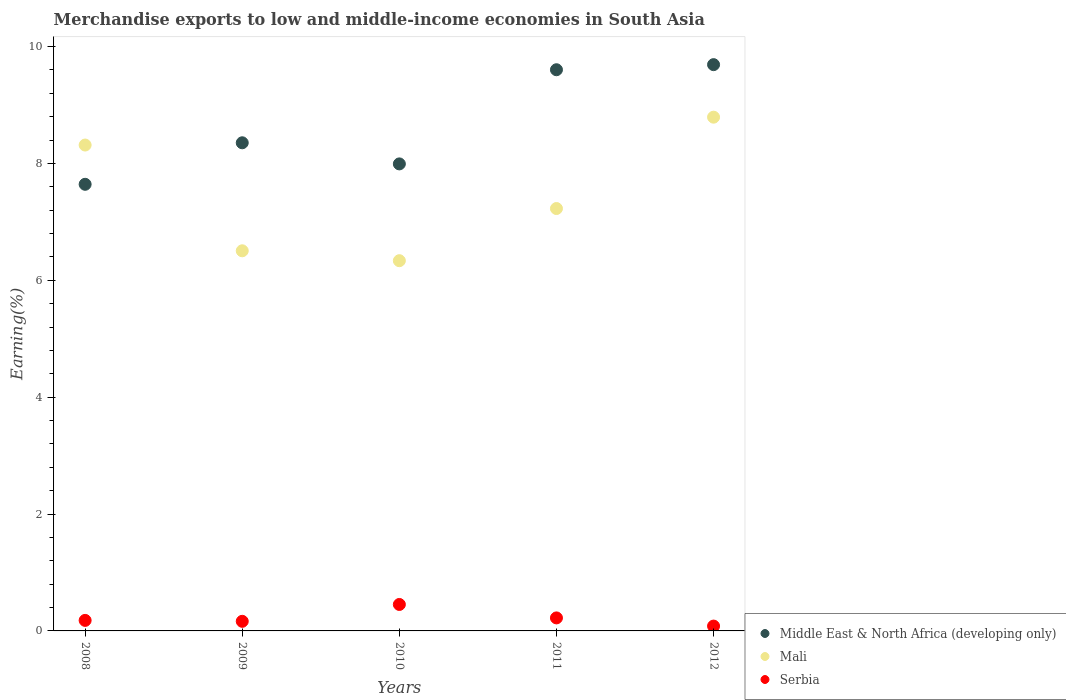How many different coloured dotlines are there?
Give a very brief answer. 3. What is the percentage of amount earned from merchandise exports in Mali in 2008?
Give a very brief answer. 8.31. Across all years, what is the maximum percentage of amount earned from merchandise exports in Serbia?
Make the answer very short. 0.45. Across all years, what is the minimum percentage of amount earned from merchandise exports in Mali?
Keep it short and to the point. 6.34. In which year was the percentage of amount earned from merchandise exports in Middle East & North Africa (developing only) maximum?
Your response must be concise. 2012. In which year was the percentage of amount earned from merchandise exports in Serbia minimum?
Your answer should be compact. 2012. What is the total percentage of amount earned from merchandise exports in Middle East & North Africa (developing only) in the graph?
Your answer should be compact. 43.28. What is the difference between the percentage of amount earned from merchandise exports in Middle East & North Africa (developing only) in 2008 and that in 2009?
Keep it short and to the point. -0.71. What is the difference between the percentage of amount earned from merchandise exports in Serbia in 2008 and the percentage of amount earned from merchandise exports in Middle East & North Africa (developing only) in 2009?
Give a very brief answer. -8.17. What is the average percentage of amount earned from merchandise exports in Mali per year?
Offer a very short reply. 7.43. In the year 2010, what is the difference between the percentage of amount earned from merchandise exports in Middle East & North Africa (developing only) and percentage of amount earned from merchandise exports in Mali?
Ensure brevity in your answer.  1.66. In how many years, is the percentage of amount earned from merchandise exports in Serbia greater than 5.2 %?
Keep it short and to the point. 0. What is the ratio of the percentage of amount earned from merchandise exports in Middle East & North Africa (developing only) in 2008 to that in 2010?
Your answer should be very brief. 0.96. Is the difference between the percentage of amount earned from merchandise exports in Middle East & North Africa (developing only) in 2009 and 2012 greater than the difference between the percentage of amount earned from merchandise exports in Mali in 2009 and 2012?
Make the answer very short. Yes. What is the difference between the highest and the second highest percentage of amount earned from merchandise exports in Serbia?
Offer a very short reply. 0.23. What is the difference between the highest and the lowest percentage of amount earned from merchandise exports in Middle East & North Africa (developing only)?
Your answer should be compact. 2.05. Is it the case that in every year, the sum of the percentage of amount earned from merchandise exports in Serbia and percentage of amount earned from merchandise exports in Mali  is greater than the percentage of amount earned from merchandise exports in Middle East & North Africa (developing only)?
Provide a short and direct response. No. Does the percentage of amount earned from merchandise exports in Middle East & North Africa (developing only) monotonically increase over the years?
Provide a succinct answer. No. What is the difference between two consecutive major ticks on the Y-axis?
Your answer should be compact. 2. Does the graph contain any zero values?
Ensure brevity in your answer.  No. Does the graph contain grids?
Offer a very short reply. No. What is the title of the graph?
Offer a terse response. Merchandise exports to low and middle-income economies in South Asia. What is the label or title of the Y-axis?
Your answer should be compact. Earning(%). What is the Earning(%) of Middle East & North Africa (developing only) in 2008?
Keep it short and to the point. 7.64. What is the Earning(%) in Mali in 2008?
Give a very brief answer. 8.31. What is the Earning(%) in Serbia in 2008?
Offer a terse response. 0.18. What is the Earning(%) of Middle East & North Africa (developing only) in 2009?
Offer a very short reply. 8.35. What is the Earning(%) of Mali in 2009?
Ensure brevity in your answer.  6.5. What is the Earning(%) of Serbia in 2009?
Provide a succinct answer. 0.16. What is the Earning(%) of Middle East & North Africa (developing only) in 2010?
Your response must be concise. 7.99. What is the Earning(%) of Mali in 2010?
Offer a terse response. 6.34. What is the Earning(%) of Serbia in 2010?
Your answer should be very brief. 0.45. What is the Earning(%) in Middle East & North Africa (developing only) in 2011?
Your answer should be compact. 9.6. What is the Earning(%) in Mali in 2011?
Offer a terse response. 7.23. What is the Earning(%) of Serbia in 2011?
Provide a short and direct response. 0.22. What is the Earning(%) in Middle East & North Africa (developing only) in 2012?
Make the answer very short. 9.69. What is the Earning(%) of Mali in 2012?
Your answer should be very brief. 8.79. What is the Earning(%) in Serbia in 2012?
Ensure brevity in your answer.  0.08. Across all years, what is the maximum Earning(%) of Middle East & North Africa (developing only)?
Keep it short and to the point. 9.69. Across all years, what is the maximum Earning(%) in Mali?
Offer a very short reply. 8.79. Across all years, what is the maximum Earning(%) in Serbia?
Ensure brevity in your answer.  0.45. Across all years, what is the minimum Earning(%) of Middle East & North Africa (developing only)?
Your answer should be very brief. 7.64. Across all years, what is the minimum Earning(%) in Mali?
Your answer should be very brief. 6.34. Across all years, what is the minimum Earning(%) in Serbia?
Make the answer very short. 0.08. What is the total Earning(%) of Middle East & North Africa (developing only) in the graph?
Provide a succinct answer. 43.28. What is the total Earning(%) of Mali in the graph?
Offer a terse response. 37.17. What is the total Earning(%) in Serbia in the graph?
Provide a succinct answer. 1.1. What is the difference between the Earning(%) in Middle East & North Africa (developing only) in 2008 and that in 2009?
Keep it short and to the point. -0.71. What is the difference between the Earning(%) of Mali in 2008 and that in 2009?
Keep it short and to the point. 1.81. What is the difference between the Earning(%) in Serbia in 2008 and that in 2009?
Your answer should be compact. 0.02. What is the difference between the Earning(%) of Middle East & North Africa (developing only) in 2008 and that in 2010?
Your response must be concise. -0.35. What is the difference between the Earning(%) in Mali in 2008 and that in 2010?
Your answer should be very brief. 1.98. What is the difference between the Earning(%) of Serbia in 2008 and that in 2010?
Make the answer very short. -0.27. What is the difference between the Earning(%) in Middle East & North Africa (developing only) in 2008 and that in 2011?
Provide a succinct answer. -1.96. What is the difference between the Earning(%) in Mali in 2008 and that in 2011?
Ensure brevity in your answer.  1.09. What is the difference between the Earning(%) in Serbia in 2008 and that in 2011?
Your answer should be compact. -0.04. What is the difference between the Earning(%) of Middle East & North Africa (developing only) in 2008 and that in 2012?
Keep it short and to the point. -2.05. What is the difference between the Earning(%) in Mali in 2008 and that in 2012?
Your response must be concise. -0.48. What is the difference between the Earning(%) in Serbia in 2008 and that in 2012?
Offer a very short reply. 0.1. What is the difference between the Earning(%) of Middle East & North Africa (developing only) in 2009 and that in 2010?
Give a very brief answer. 0.36. What is the difference between the Earning(%) in Mali in 2009 and that in 2010?
Your answer should be very brief. 0.17. What is the difference between the Earning(%) of Serbia in 2009 and that in 2010?
Your answer should be compact. -0.29. What is the difference between the Earning(%) in Middle East & North Africa (developing only) in 2009 and that in 2011?
Give a very brief answer. -1.25. What is the difference between the Earning(%) of Mali in 2009 and that in 2011?
Your response must be concise. -0.72. What is the difference between the Earning(%) in Serbia in 2009 and that in 2011?
Provide a succinct answer. -0.06. What is the difference between the Earning(%) in Middle East & North Africa (developing only) in 2009 and that in 2012?
Your answer should be compact. -1.34. What is the difference between the Earning(%) of Mali in 2009 and that in 2012?
Your response must be concise. -2.29. What is the difference between the Earning(%) in Serbia in 2009 and that in 2012?
Offer a terse response. 0.08. What is the difference between the Earning(%) of Middle East & North Africa (developing only) in 2010 and that in 2011?
Your response must be concise. -1.61. What is the difference between the Earning(%) in Mali in 2010 and that in 2011?
Your response must be concise. -0.89. What is the difference between the Earning(%) of Serbia in 2010 and that in 2011?
Keep it short and to the point. 0.23. What is the difference between the Earning(%) in Middle East & North Africa (developing only) in 2010 and that in 2012?
Your answer should be very brief. -1.7. What is the difference between the Earning(%) in Mali in 2010 and that in 2012?
Keep it short and to the point. -2.46. What is the difference between the Earning(%) in Serbia in 2010 and that in 2012?
Give a very brief answer. 0.37. What is the difference between the Earning(%) in Middle East & North Africa (developing only) in 2011 and that in 2012?
Offer a very short reply. -0.09. What is the difference between the Earning(%) of Mali in 2011 and that in 2012?
Your response must be concise. -1.56. What is the difference between the Earning(%) in Serbia in 2011 and that in 2012?
Your answer should be compact. 0.14. What is the difference between the Earning(%) of Middle East & North Africa (developing only) in 2008 and the Earning(%) of Mali in 2009?
Your response must be concise. 1.14. What is the difference between the Earning(%) of Middle East & North Africa (developing only) in 2008 and the Earning(%) of Serbia in 2009?
Offer a terse response. 7.48. What is the difference between the Earning(%) in Mali in 2008 and the Earning(%) in Serbia in 2009?
Your answer should be compact. 8.15. What is the difference between the Earning(%) in Middle East & North Africa (developing only) in 2008 and the Earning(%) in Mali in 2010?
Give a very brief answer. 1.31. What is the difference between the Earning(%) in Middle East & North Africa (developing only) in 2008 and the Earning(%) in Serbia in 2010?
Provide a succinct answer. 7.19. What is the difference between the Earning(%) in Mali in 2008 and the Earning(%) in Serbia in 2010?
Offer a terse response. 7.86. What is the difference between the Earning(%) in Middle East & North Africa (developing only) in 2008 and the Earning(%) in Mali in 2011?
Offer a terse response. 0.41. What is the difference between the Earning(%) of Middle East & North Africa (developing only) in 2008 and the Earning(%) of Serbia in 2011?
Offer a very short reply. 7.42. What is the difference between the Earning(%) of Mali in 2008 and the Earning(%) of Serbia in 2011?
Provide a short and direct response. 8.09. What is the difference between the Earning(%) of Middle East & North Africa (developing only) in 2008 and the Earning(%) of Mali in 2012?
Your response must be concise. -1.15. What is the difference between the Earning(%) of Middle East & North Africa (developing only) in 2008 and the Earning(%) of Serbia in 2012?
Your answer should be compact. 7.56. What is the difference between the Earning(%) in Mali in 2008 and the Earning(%) in Serbia in 2012?
Provide a short and direct response. 8.23. What is the difference between the Earning(%) of Middle East & North Africa (developing only) in 2009 and the Earning(%) of Mali in 2010?
Provide a short and direct response. 2.02. What is the difference between the Earning(%) of Middle East & North Africa (developing only) in 2009 and the Earning(%) of Serbia in 2010?
Offer a terse response. 7.9. What is the difference between the Earning(%) in Mali in 2009 and the Earning(%) in Serbia in 2010?
Offer a very short reply. 6.05. What is the difference between the Earning(%) in Middle East & North Africa (developing only) in 2009 and the Earning(%) in Mali in 2011?
Provide a short and direct response. 1.12. What is the difference between the Earning(%) in Middle East & North Africa (developing only) in 2009 and the Earning(%) in Serbia in 2011?
Provide a succinct answer. 8.13. What is the difference between the Earning(%) of Mali in 2009 and the Earning(%) of Serbia in 2011?
Make the answer very short. 6.28. What is the difference between the Earning(%) of Middle East & North Africa (developing only) in 2009 and the Earning(%) of Mali in 2012?
Make the answer very short. -0.44. What is the difference between the Earning(%) in Middle East & North Africa (developing only) in 2009 and the Earning(%) in Serbia in 2012?
Ensure brevity in your answer.  8.27. What is the difference between the Earning(%) in Mali in 2009 and the Earning(%) in Serbia in 2012?
Your answer should be very brief. 6.42. What is the difference between the Earning(%) in Middle East & North Africa (developing only) in 2010 and the Earning(%) in Mali in 2011?
Offer a terse response. 0.76. What is the difference between the Earning(%) in Middle East & North Africa (developing only) in 2010 and the Earning(%) in Serbia in 2011?
Keep it short and to the point. 7.77. What is the difference between the Earning(%) in Mali in 2010 and the Earning(%) in Serbia in 2011?
Make the answer very short. 6.11. What is the difference between the Earning(%) in Middle East & North Africa (developing only) in 2010 and the Earning(%) in Mali in 2012?
Your answer should be compact. -0.8. What is the difference between the Earning(%) of Middle East & North Africa (developing only) in 2010 and the Earning(%) of Serbia in 2012?
Make the answer very short. 7.91. What is the difference between the Earning(%) of Mali in 2010 and the Earning(%) of Serbia in 2012?
Your answer should be very brief. 6.25. What is the difference between the Earning(%) in Middle East & North Africa (developing only) in 2011 and the Earning(%) in Mali in 2012?
Provide a succinct answer. 0.81. What is the difference between the Earning(%) in Middle East & North Africa (developing only) in 2011 and the Earning(%) in Serbia in 2012?
Keep it short and to the point. 9.52. What is the difference between the Earning(%) in Mali in 2011 and the Earning(%) in Serbia in 2012?
Offer a very short reply. 7.14. What is the average Earning(%) of Middle East & North Africa (developing only) per year?
Make the answer very short. 8.66. What is the average Earning(%) of Mali per year?
Provide a short and direct response. 7.43. What is the average Earning(%) in Serbia per year?
Your answer should be very brief. 0.22. In the year 2008, what is the difference between the Earning(%) in Middle East & North Africa (developing only) and Earning(%) in Mali?
Your answer should be very brief. -0.67. In the year 2008, what is the difference between the Earning(%) of Middle East & North Africa (developing only) and Earning(%) of Serbia?
Your answer should be compact. 7.46. In the year 2008, what is the difference between the Earning(%) in Mali and Earning(%) in Serbia?
Keep it short and to the point. 8.13. In the year 2009, what is the difference between the Earning(%) in Middle East & North Africa (developing only) and Earning(%) in Mali?
Make the answer very short. 1.85. In the year 2009, what is the difference between the Earning(%) in Middle East & North Africa (developing only) and Earning(%) in Serbia?
Provide a succinct answer. 8.19. In the year 2009, what is the difference between the Earning(%) of Mali and Earning(%) of Serbia?
Offer a terse response. 6.34. In the year 2010, what is the difference between the Earning(%) of Middle East & North Africa (developing only) and Earning(%) of Mali?
Offer a very short reply. 1.66. In the year 2010, what is the difference between the Earning(%) in Middle East & North Africa (developing only) and Earning(%) in Serbia?
Your response must be concise. 7.54. In the year 2010, what is the difference between the Earning(%) of Mali and Earning(%) of Serbia?
Your answer should be compact. 5.88. In the year 2011, what is the difference between the Earning(%) in Middle East & North Africa (developing only) and Earning(%) in Mali?
Make the answer very short. 2.37. In the year 2011, what is the difference between the Earning(%) in Middle East & North Africa (developing only) and Earning(%) in Serbia?
Your response must be concise. 9.38. In the year 2011, what is the difference between the Earning(%) in Mali and Earning(%) in Serbia?
Offer a very short reply. 7.01. In the year 2012, what is the difference between the Earning(%) of Middle East & North Africa (developing only) and Earning(%) of Mali?
Offer a very short reply. 0.9. In the year 2012, what is the difference between the Earning(%) in Middle East & North Africa (developing only) and Earning(%) in Serbia?
Provide a succinct answer. 9.61. In the year 2012, what is the difference between the Earning(%) of Mali and Earning(%) of Serbia?
Make the answer very short. 8.71. What is the ratio of the Earning(%) in Middle East & North Africa (developing only) in 2008 to that in 2009?
Keep it short and to the point. 0.92. What is the ratio of the Earning(%) in Mali in 2008 to that in 2009?
Make the answer very short. 1.28. What is the ratio of the Earning(%) of Serbia in 2008 to that in 2009?
Provide a short and direct response. 1.1. What is the ratio of the Earning(%) in Middle East & North Africa (developing only) in 2008 to that in 2010?
Your answer should be compact. 0.96. What is the ratio of the Earning(%) in Mali in 2008 to that in 2010?
Your answer should be compact. 1.31. What is the ratio of the Earning(%) in Serbia in 2008 to that in 2010?
Your answer should be very brief. 0.4. What is the ratio of the Earning(%) in Middle East & North Africa (developing only) in 2008 to that in 2011?
Offer a very short reply. 0.8. What is the ratio of the Earning(%) in Mali in 2008 to that in 2011?
Offer a very short reply. 1.15. What is the ratio of the Earning(%) in Serbia in 2008 to that in 2011?
Your answer should be very brief. 0.81. What is the ratio of the Earning(%) of Middle East & North Africa (developing only) in 2008 to that in 2012?
Keep it short and to the point. 0.79. What is the ratio of the Earning(%) of Mali in 2008 to that in 2012?
Provide a succinct answer. 0.95. What is the ratio of the Earning(%) of Serbia in 2008 to that in 2012?
Your response must be concise. 2.17. What is the ratio of the Earning(%) of Middle East & North Africa (developing only) in 2009 to that in 2010?
Ensure brevity in your answer.  1.05. What is the ratio of the Earning(%) in Mali in 2009 to that in 2010?
Give a very brief answer. 1.03. What is the ratio of the Earning(%) of Serbia in 2009 to that in 2010?
Ensure brevity in your answer.  0.36. What is the ratio of the Earning(%) in Middle East & North Africa (developing only) in 2009 to that in 2011?
Provide a short and direct response. 0.87. What is the ratio of the Earning(%) in Mali in 2009 to that in 2011?
Your answer should be very brief. 0.9. What is the ratio of the Earning(%) of Serbia in 2009 to that in 2011?
Your answer should be very brief. 0.74. What is the ratio of the Earning(%) in Middle East & North Africa (developing only) in 2009 to that in 2012?
Keep it short and to the point. 0.86. What is the ratio of the Earning(%) of Mali in 2009 to that in 2012?
Provide a succinct answer. 0.74. What is the ratio of the Earning(%) in Serbia in 2009 to that in 2012?
Provide a succinct answer. 1.98. What is the ratio of the Earning(%) of Middle East & North Africa (developing only) in 2010 to that in 2011?
Provide a succinct answer. 0.83. What is the ratio of the Earning(%) of Mali in 2010 to that in 2011?
Ensure brevity in your answer.  0.88. What is the ratio of the Earning(%) of Serbia in 2010 to that in 2011?
Provide a succinct answer. 2.03. What is the ratio of the Earning(%) of Middle East & North Africa (developing only) in 2010 to that in 2012?
Ensure brevity in your answer.  0.82. What is the ratio of the Earning(%) of Mali in 2010 to that in 2012?
Provide a short and direct response. 0.72. What is the ratio of the Earning(%) of Serbia in 2010 to that in 2012?
Offer a terse response. 5.47. What is the ratio of the Earning(%) in Middle East & North Africa (developing only) in 2011 to that in 2012?
Provide a short and direct response. 0.99. What is the ratio of the Earning(%) in Mali in 2011 to that in 2012?
Offer a terse response. 0.82. What is the ratio of the Earning(%) of Serbia in 2011 to that in 2012?
Your response must be concise. 2.69. What is the difference between the highest and the second highest Earning(%) in Middle East & North Africa (developing only)?
Your answer should be compact. 0.09. What is the difference between the highest and the second highest Earning(%) of Mali?
Your answer should be very brief. 0.48. What is the difference between the highest and the second highest Earning(%) of Serbia?
Ensure brevity in your answer.  0.23. What is the difference between the highest and the lowest Earning(%) in Middle East & North Africa (developing only)?
Ensure brevity in your answer.  2.05. What is the difference between the highest and the lowest Earning(%) in Mali?
Keep it short and to the point. 2.46. What is the difference between the highest and the lowest Earning(%) in Serbia?
Keep it short and to the point. 0.37. 